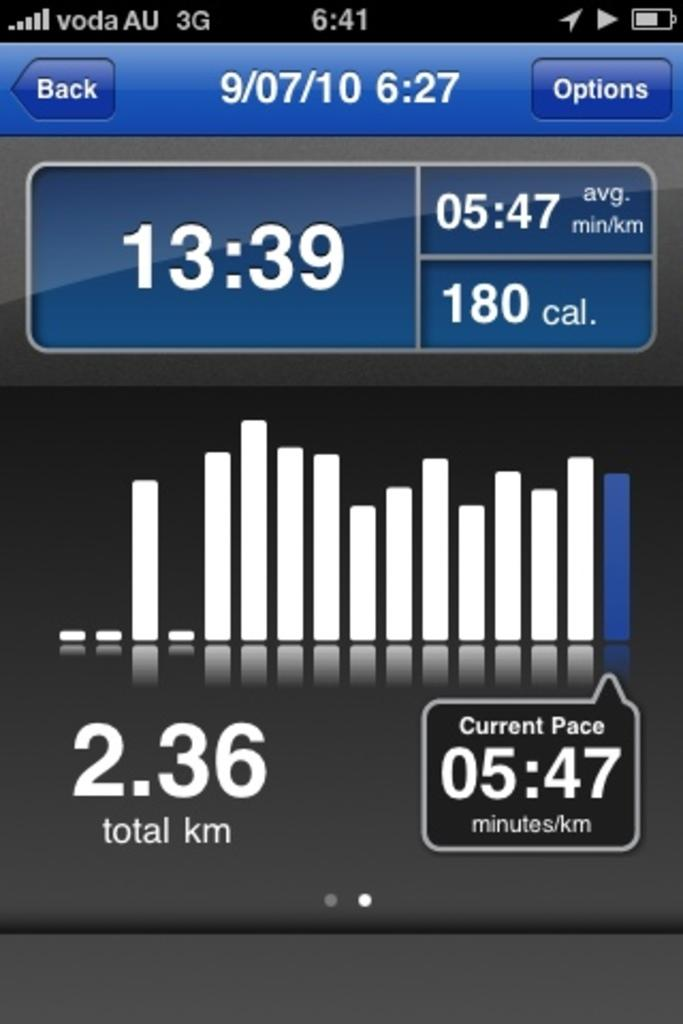<image>
Share a concise interpretation of the image provided. A phone screen shows an app that shows 2.36 total km and a current pace of 05:47 minutes per km. 